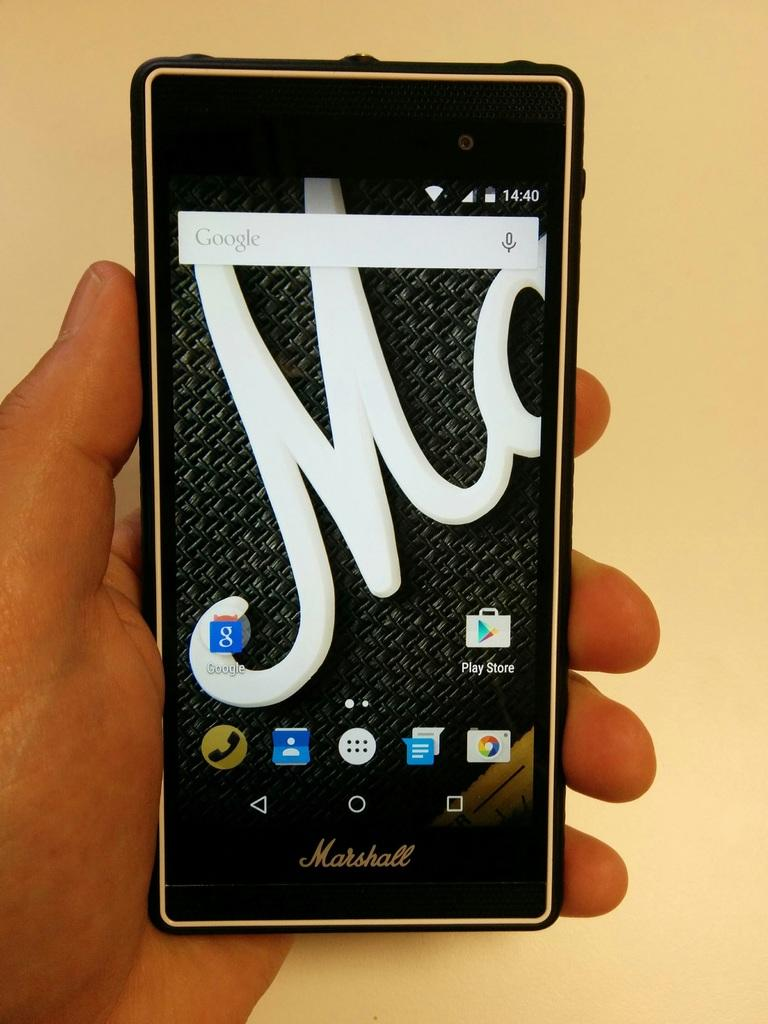<image>
Render a clear and concise summary of the photo. A person is holding a cell phone in their hand with the time reading 14:40. 